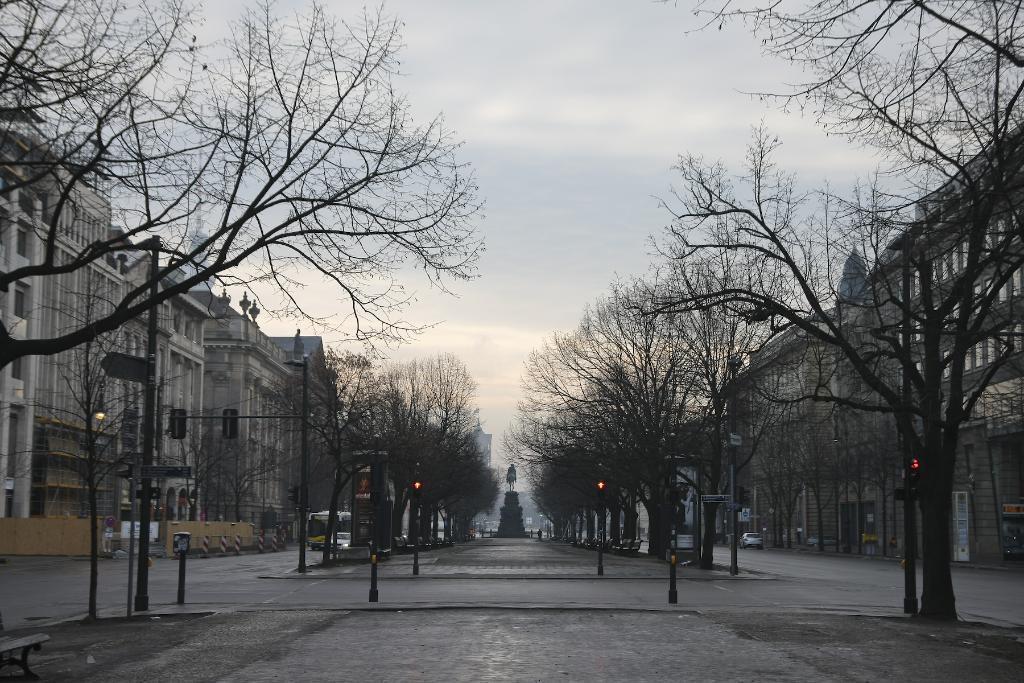Describe this image in one or two sentences. In this picture we can see a statue on the path and on the left and right side of the statue there are trees, poles with lights, vehicles on the road, buildings and other objects. Behind the statue there is a sky. 